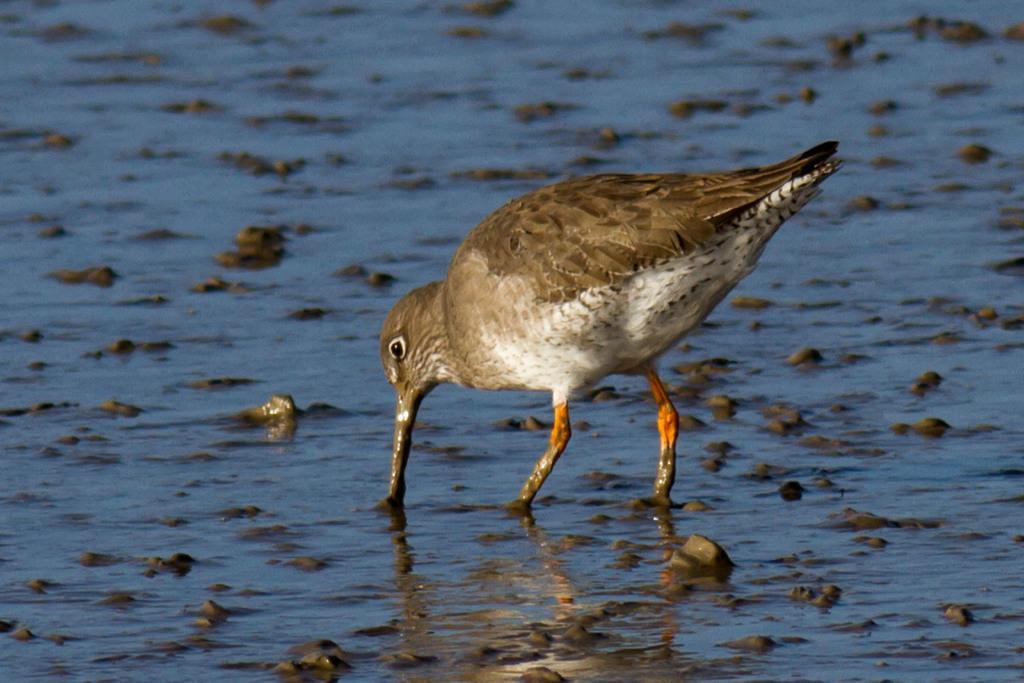Can you describe this image briefly? In this image in the center there is one bird which is in a water, and at the bottom there is a sea, in that sea there are some stones. 